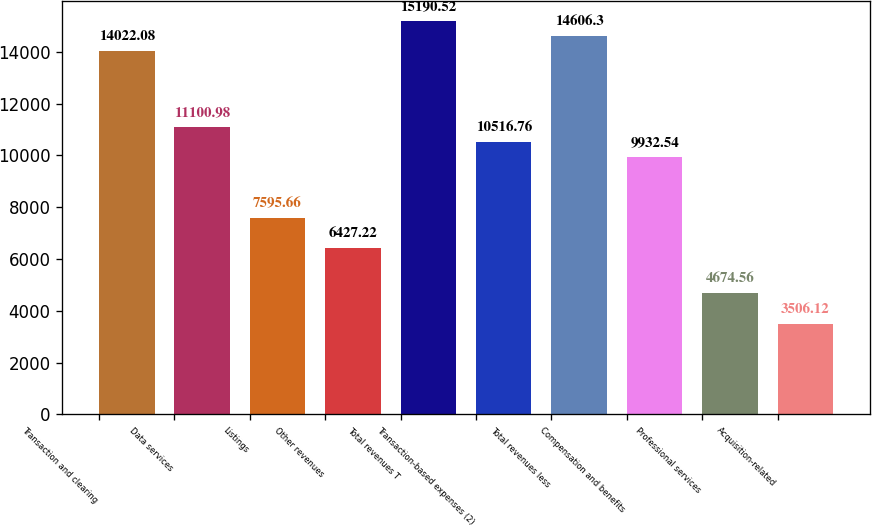<chart> <loc_0><loc_0><loc_500><loc_500><bar_chart><fcel>Transaction and clearing<fcel>Data services<fcel>Listings<fcel>Other revenues<fcel>Total revenues T<fcel>Transaction-based expenses (2)<fcel>Total revenues less<fcel>Compensation and benefits<fcel>Professional services<fcel>Acquisition-related<nl><fcel>14022.1<fcel>11101<fcel>7595.66<fcel>6427.22<fcel>15190.5<fcel>10516.8<fcel>14606.3<fcel>9932.54<fcel>4674.56<fcel>3506.12<nl></chart> 